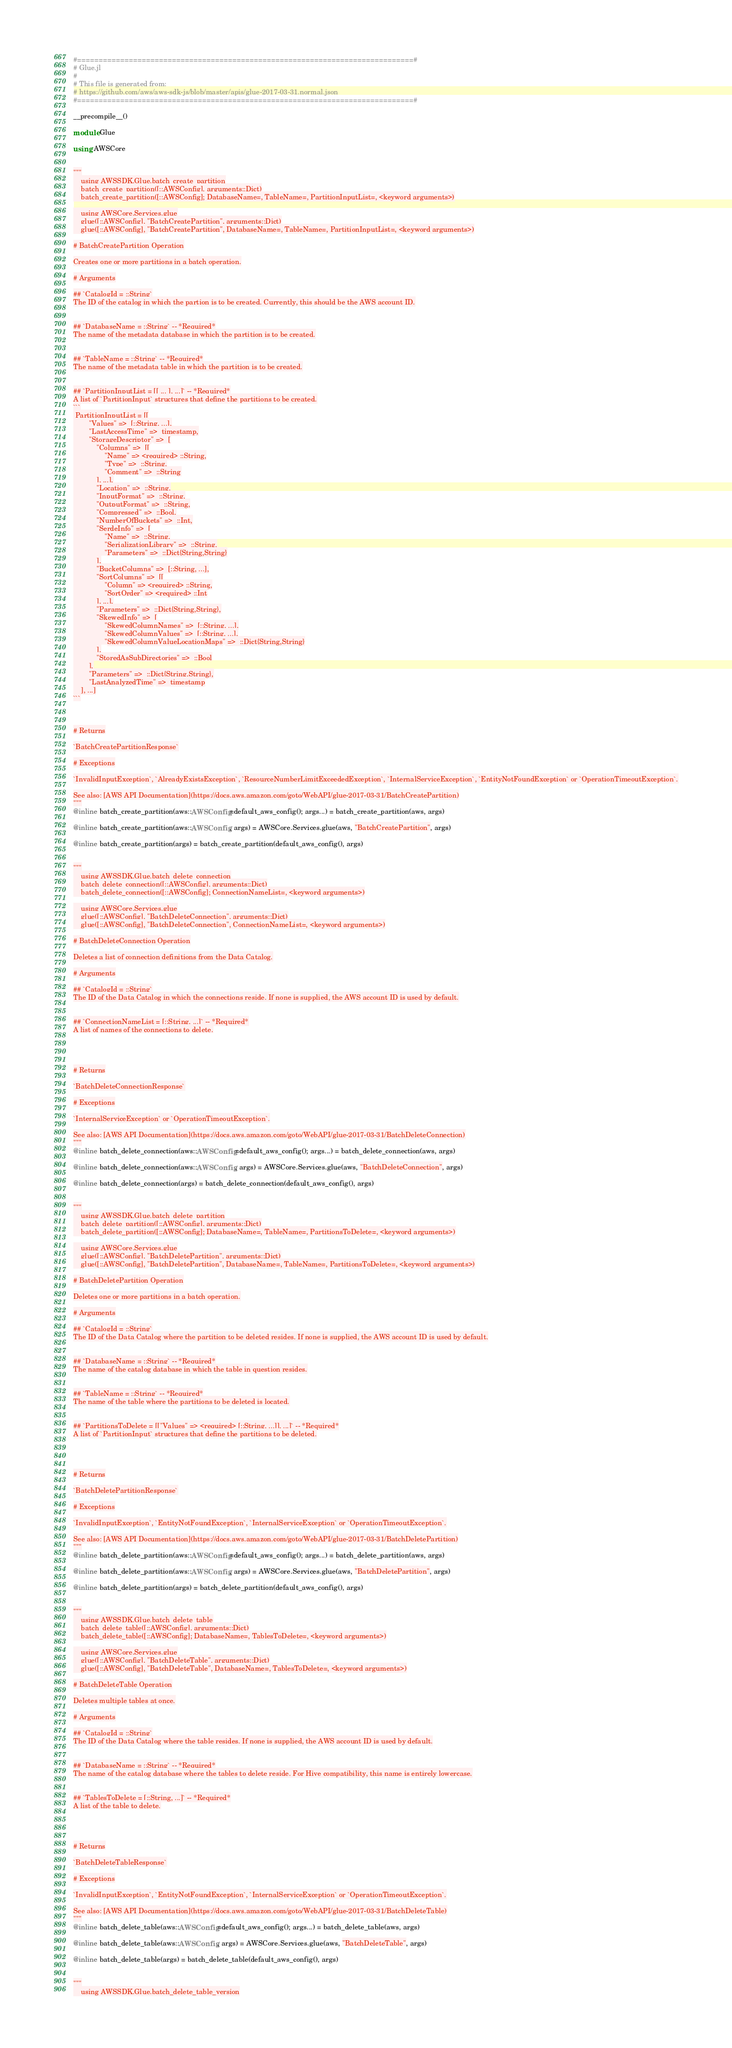<code> <loc_0><loc_0><loc_500><loc_500><_Julia_>#==============================================================================#
# Glue.jl
#
# This file is generated from:
# https://github.com/aws/aws-sdk-js/blob/master/apis/glue-2017-03-31.normal.json
#==============================================================================#

__precompile__()

module Glue

using AWSCore


"""
    using AWSSDK.Glue.batch_create_partition
    batch_create_partition([::AWSConfig], arguments::Dict)
    batch_create_partition([::AWSConfig]; DatabaseName=, TableName=, PartitionInputList=, <keyword arguments>)

    using AWSCore.Services.glue
    glue([::AWSConfig], "BatchCreatePartition", arguments::Dict)
    glue([::AWSConfig], "BatchCreatePartition", DatabaseName=, TableName=, PartitionInputList=, <keyword arguments>)

# BatchCreatePartition Operation

Creates one or more partitions in a batch operation.

# Arguments

## `CatalogId = ::String`
The ID of the catalog in which the partion is to be created. Currently, this should be the AWS account ID.


## `DatabaseName = ::String` -- *Required*
The name of the metadata database in which the partition is to be created.


## `TableName = ::String` -- *Required*
The name of the metadata table in which the partition is to be created.


## `PartitionInputList = [[ ... ], ...]` -- *Required*
A list of `PartitionInput` structures that define the partitions to be created.
```
 PartitionInputList = [[
        "Values" =>  [::String, ...],
        "LastAccessTime" =>  timestamp,
        "StorageDescriptor" =>  [
            "Columns" =>  [[
                "Name" => <required> ::String,
                "Type" =>  ::String,
                "Comment" =>  ::String
            ], ...],
            "Location" =>  ::String,
            "InputFormat" =>  ::String,
            "OutputFormat" =>  ::String,
            "Compressed" =>  ::Bool,
            "NumberOfBuckets" =>  ::Int,
            "SerdeInfo" =>  [
                "Name" =>  ::String,
                "SerializationLibrary" =>  ::String,
                "Parameters" =>  ::Dict{String,String}
            ],
            "BucketColumns" =>  [::String, ...],
            "SortColumns" =>  [[
                "Column" => <required> ::String,
                "SortOrder" => <required> ::Int
            ], ...],
            "Parameters" =>  ::Dict{String,String},
            "SkewedInfo" =>  [
                "SkewedColumnNames" =>  [::String, ...],
                "SkewedColumnValues" =>  [::String, ...],
                "SkewedColumnValueLocationMaps" =>  ::Dict{String,String}
            ],
            "StoredAsSubDirectories" =>  ::Bool
        ],
        "Parameters" =>  ::Dict{String,String},
        "LastAnalyzedTime" =>  timestamp
    ], ...]
```



# Returns

`BatchCreatePartitionResponse`

# Exceptions

`InvalidInputException`, `AlreadyExistsException`, `ResourceNumberLimitExceededException`, `InternalServiceException`, `EntityNotFoundException` or `OperationTimeoutException`.

See also: [AWS API Documentation](https://docs.aws.amazon.com/goto/WebAPI/glue-2017-03-31/BatchCreatePartition)
"""
@inline batch_create_partition(aws::AWSConfig=default_aws_config(); args...) = batch_create_partition(aws, args)

@inline batch_create_partition(aws::AWSConfig, args) = AWSCore.Services.glue(aws, "BatchCreatePartition", args)

@inline batch_create_partition(args) = batch_create_partition(default_aws_config(), args)


"""
    using AWSSDK.Glue.batch_delete_connection
    batch_delete_connection([::AWSConfig], arguments::Dict)
    batch_delete_connection([::AWSConfig]; ConnectionNameList=, <keyword arguments>)

    using AWSCore.Services.glue
    glue([::AWSConfig], "BatchDeleteConnection", arguments::Dict)
    glue([::AWSConfig], "BatchDeleteConnection", ConnectionNameList=, <keyword arguments>)

# BatchDeleteConnection Operation

Deletes a list of connection definitions from the Data Catalog.

# Arguments

## `CatalogId = ::String`
The ID of the Data Catalog in which the connections reside. If none is supplied, the AWS account ID is used by default.


## `ConnectionNameList = [::String, ...]` -- *Required*
A list of names of the connections to delete.




# Returns

`BatchDeleteConnectionResponse`

# Exceptions

`InternalServiceException` or `OperationTimeoutException`.

See also: [AWS API Documentation](https://docs.aws.amazon.com/goto/WebAPI/glue-2017-03-31/BatchDeleteConnection)
"""
@inline batch_delete_connection(aws::AWSConfig=default_aws_config(); args...) = batch_delete_connection(aws, args)

@inline batch_delete_connection(aws::AWSConfig, args) = AWSCore.Services.glue(aws, "BatchDeleteConnection", args)

@inline batch_delete_connection(args) = batch_delete_connection(default_aws_config(), args)


"""
    using AWSSDK.Glue.batch_delete_partition
    batch_delete_partition([::AWSConfig], arguments::Dict)
    batch_delete_partition([::AWSConfig]; DatabaseName=, TableName=, PartitionsToDelete=, <keyword arguments>)

    using AWSCore.Services.glue
    glue([::AWSConfig], "BatchDeletePartition", arguments::Dict)
    glue([::AWSConfig], "BatchDeletePartition", DatabaseName=, TableName=, PartitionsToDelete=, <keyword arguments>)

# BatchDeletePartition Operation

Deletes one or more partitions in a batch operation.

# Arguments

## `CatalogId = ::String`
The ID of the Data Catalog where the partition to be deleted resides. If none is supplied, the AWS account ID is used by default.


## `DatabaseName = ::String` -- *Required*
The name of the catalog database in which the table in question resides.


## `TableName = ::String` -- *Required*
The name of the table where the partitions to be deleted is located.


## `PartitionsToDelete = [["Values" => <required> [::String, ...]], ...]` -- *Required*
A list of `PartitionInput` structures that define the partitions to be deleted.




# Returns

`BatchDeletePartitionResponse`

# Exceptions

`InvalidInputException`, `EntityNotFoundException`, `InternalServiceException` or `OperationTimeoutException`.

See also: [AWS API Documentation](https://docs.aws.amazon.com/goto/WebAPI/glue-2017-03-31/BatchDeletePartition)
"""
@inline batch_delete_partition(aws::AWSConfig=default_aws_config(); args...) = batch_delete_partition(aws, args)

@inline batch_delete_partition(aws::AWSConfig, args) = AWSCore.Services.glue(aws, "BatchDeletePartition", args)

@inline batch_delete_partition(args) = batch_delete_partition(default_aws_config(), args)


"""
    using AWSSDK.Glue.batch_delete_table
    batch_delete_table([::AWSConfig], arguments::Dict)
    batch_delete_table([::AWSConfig]; DatabaseName=, TablesToDelete=, <keyword arguments>)

    using AWSCore.Services.glue
    glue([::AWSConfig], "BatchDeleteTable", arguments::Dict)
    glue([::AWSConfig], "BatchDeleteTable", DatabaseName=, TablesToDelete=, <keyword arguments>)

# BatchDeleteTable Operation

Deletes multiple tables at once.

# Arguments

## `CatalogId = ::String`
The ID of the Data Catalog where the table resides. If none is supplied, the AWS account ID is used by default.


## `DatabaseName = ::String` -- *Required*
The name of the catalog database where the tables to delete reside. For Hive compatibility, this name is entirely lowercase.


## `TablesToDelete = [::String, ...]` -- *Required*
A list of the table to delete.




# Returns

`BatchDeleteTableResponse`

# Exceptions

`InvalidInputException`, `EntityNotFoundException`, `InternalServiceException` or `OperationTimeoutException`.

See also: [AWS API Documentation](https://docs.aws.amazon.com/goto/WebAPI/glue-2017-03-31/BatchDeleteTable)
"""
@inline batch_delete_table(aws::AWSConfig=default_aws_config(); args...) = batch_delete_table(aws, args)

@inline batch_delete_table(aws::AWSConfig, args) = AWSCore.Services.glue(aws, "BatchDeleteTable", args)

@inline batch_delete_table(args) = batch_delete_table(default_aws_config(), args)


"""
    using AWSSDK.Glue.batch_delete_table_version</code> 